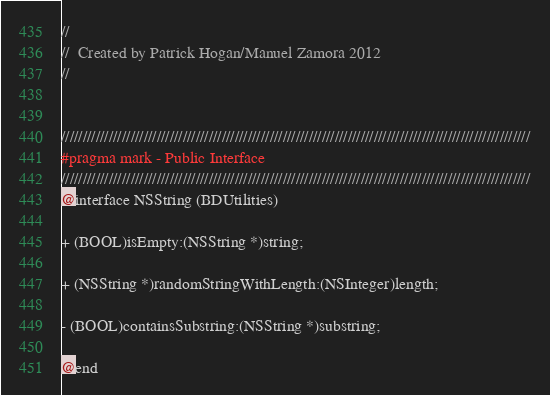<code> <loc_0><loc_0><loc_500><loc_500><_C_>//
//  Created by Patrick Hogan/Manuel Zamora 2012
//


////////////////////////////////////////////////////////////////////////////////////////////////////////////
#pragma mark - Public Interface
////////////////////////////////////////////////////////////////////////////////////////////////////////////
@interface NSString (BDUtilities)

+ (BOOL)isEmpty:(NSString *)string;

+ (NSString *)randomStringWithLength:(NSInteger)length;

- (BOOL)containsSubstring:(NSString *)substring;

@end
</code> 